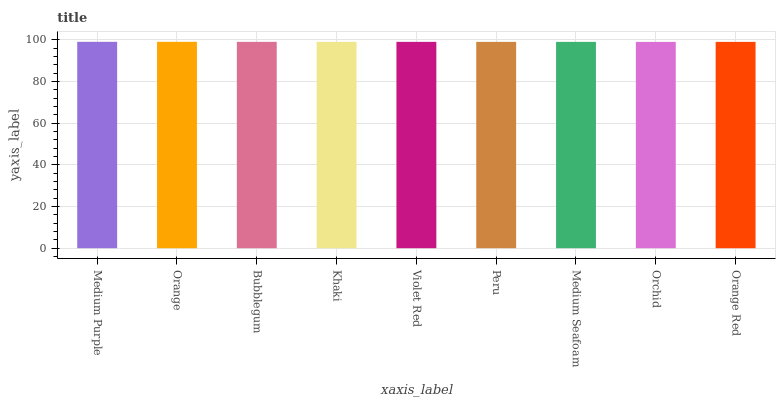Is Orange the minimum?
Answer yes or no. No. Is Orange the maximum?
Answer yes or no. No. Is Medium Purple greater than Orange?
Answer yes or no. Yes. Is Orange less than Medium Purple?
Answer yes or no. Yes. Is Orange greater than Medium Purple?
Answer yes or no. No. Is Medium Purple less than Orange?
Answer yes or no. No. Is Violet Red the high median?
Answer yes or no. Yes. Is Violet Red the low median?
Answer yes or no. Yes. Is Peru the high median?
Answer yes or no. No. Is Orchid the low median?
Answer yes or no. No. 